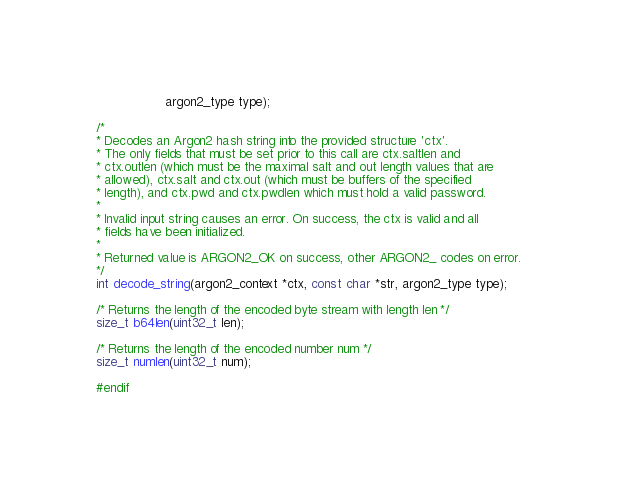<code> <loc_0><loc_0><loc_500><loc_500><_C_>                  argon2_type type);

/*
* Decodes an Argon2 hash string into the provided structure 'ctx'.
* The only fields that must be set prior to this call are ctx.saltlen and
* ctx.outlen (which must be the maximal salt and out length values that are
* allowed), ctx.salt and ctx.out (which must be buffers of the specified
* length), and ctx.pwd and ctx.pwdlen which must hold a valid password.
*
* Invalid input string causes an error. On success, the ctx is valid and all
* fields have been initialized.
*
* Returned value is ARGON2_OK on success, other ARGON2_ codes on error.
*/
int decode_string(argon2_context *ctx, const char *str, argon2_type type);

/* Returns the length of the encoded byte stream with length len */
size_t b64len(uint32_t len);

/* Returns the length of the encoded number num */
size_t numlen(uint32_t num);

#endif
</code> 